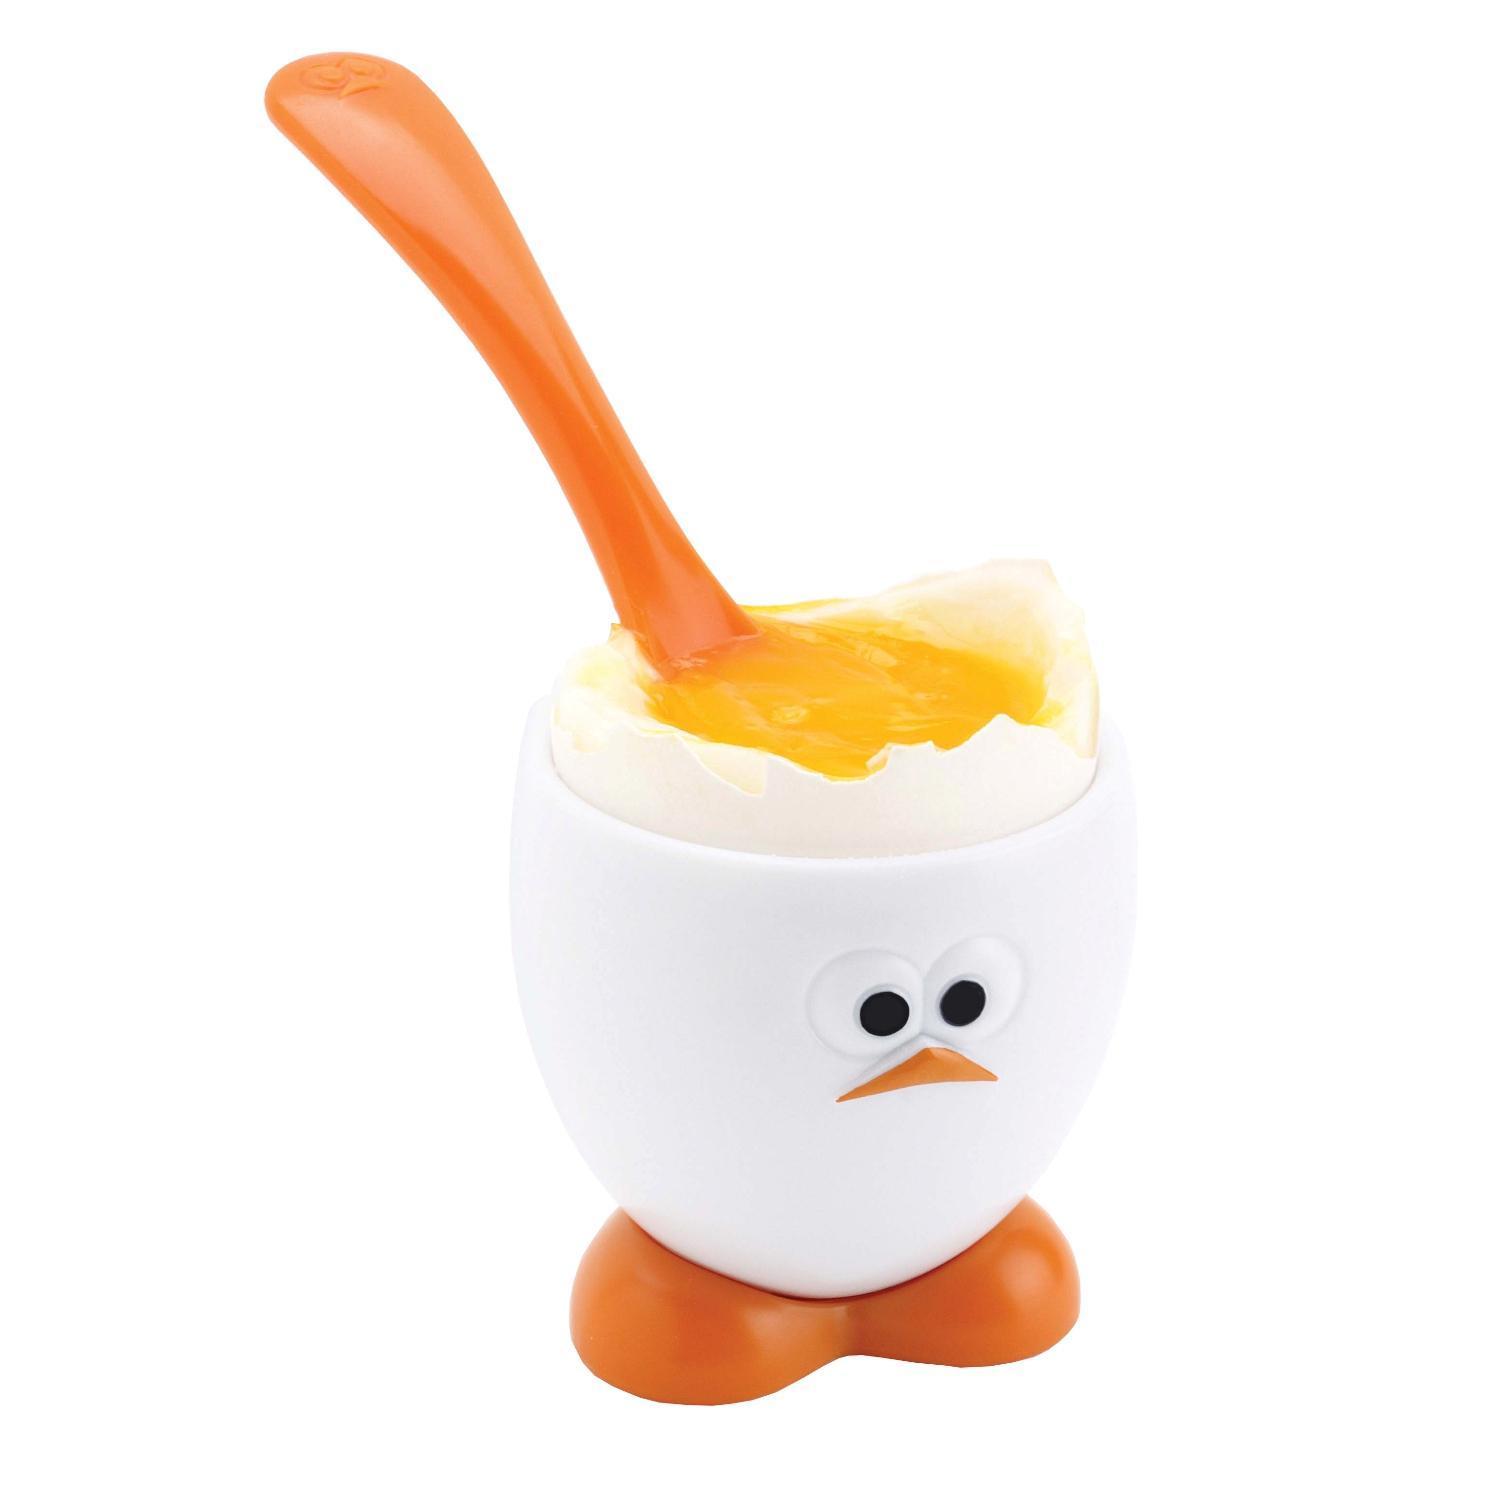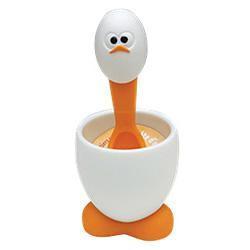The first image is the image on the left, the second image is the image on the right. Evaluate the accuracy of this statement regarding the images: "One image shows a spoon inserted in yolk in the egg-shaped cup with orange feet.". Is it true? Answer yes or no. Yes. 